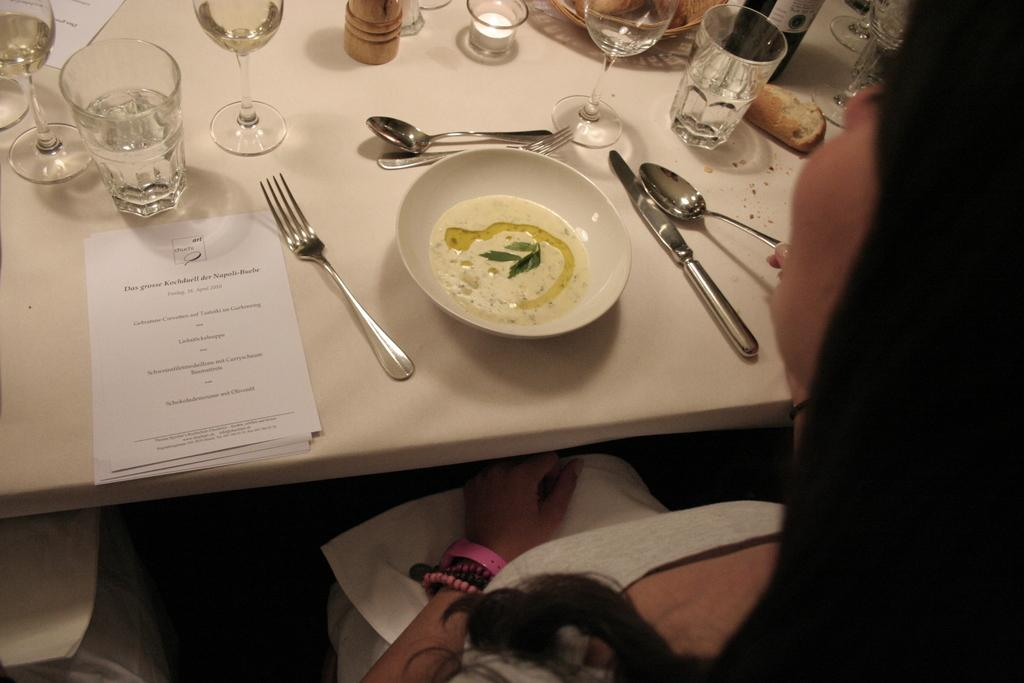What is present in the image? There is a person, a table, spoons, a plate, glasses, and a paper in the image. Can you describe the person in the image? The provided facts do not give any information about the person's appearance or clothing. What is on the table in the image? There are spoons, a plate, glasses, and a paper on the table in the image. How many glasses are on the table? There is no specific number of glasses mentioned in the provided facts. What type of apple is being used as a centerpiece on the table? There is no apple present on the table in the image. How many trains are visible in the image? There are no trains present in the image. 